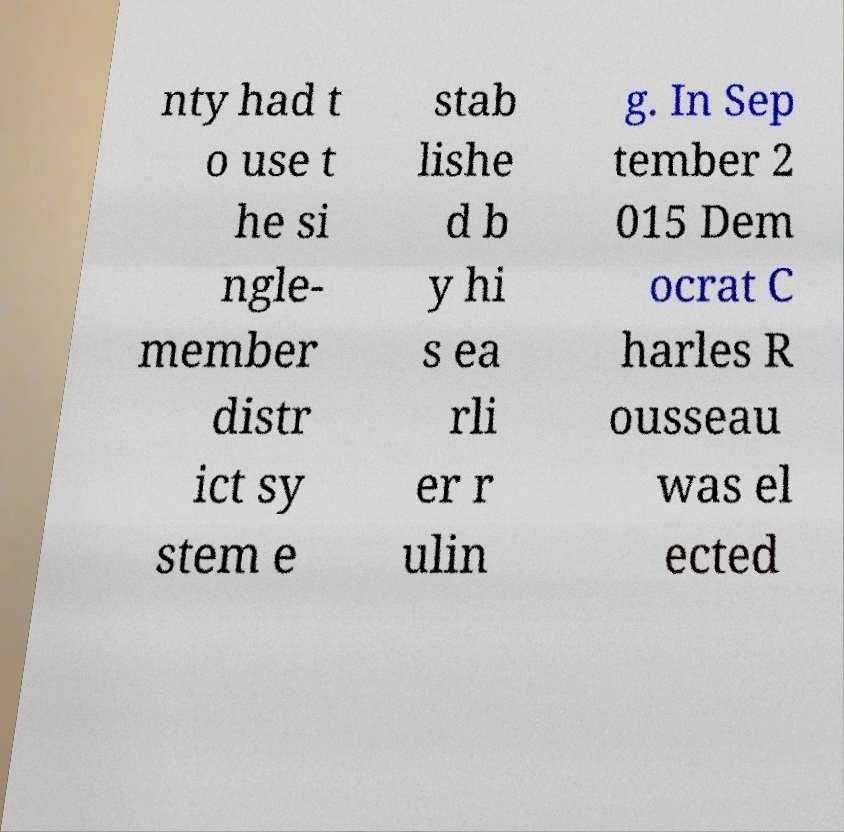There's text embedded in this image that I need extracted. Can you transcribe it verbatim? nty had t o use t he si ngle- member distr ict sy stem e stab lishe d b y hi s ea rli er r ulin g. In Sep tember 2 015 Dem ocrat C harles R ousseau was el ected 